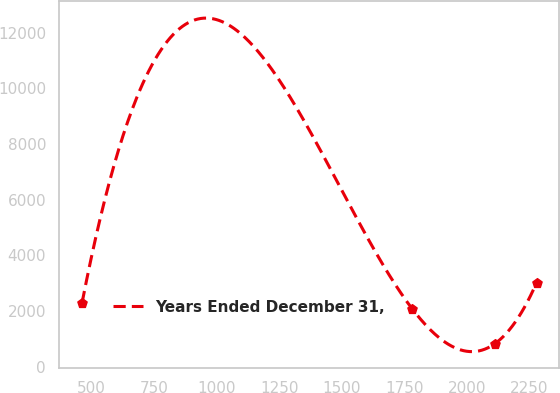<chart> <loc_0><loc_0><loc_500><loc_500><line_chart><ecel><fcel>Years Ended December 31,<nl><fcel>460.97<fcel>2288.94<nl><fcel>1782.37<fcel>2069.67<nl><fcel>2112.01<fcel>825.08<nl><fcel>2278.98<fcel>3017.74<nl></chart> 